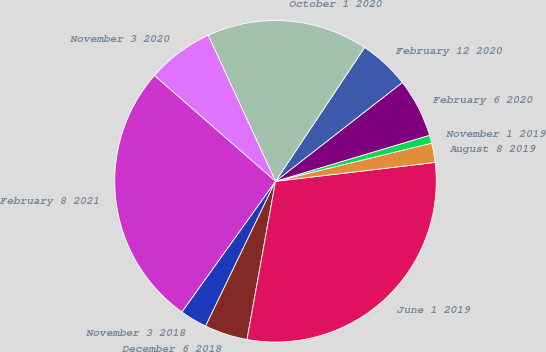Convert chart. <chart><loc_0><loc_0><loc_500><loc_500><pie_chart><fcel>November 3 2018<fcel>December 6 2018<fcel>June 1 2019<fcel>August 8 2019<fcel>November 1 2019<fcel>February 6 2020<fcel>February 12 2020<fcel>October 1 2020<fcel>November 3 2020<fcel>February 8 2021<nl><fcel>2.74%<fcel>4.32%<fcel>29.71%<fcel>1.94%<fcel>0.81%<fcel>5.91%<fcel>5.12%<fcel>16.22%<fcel>6.7%<fcel>26.53%<nl></chart> 